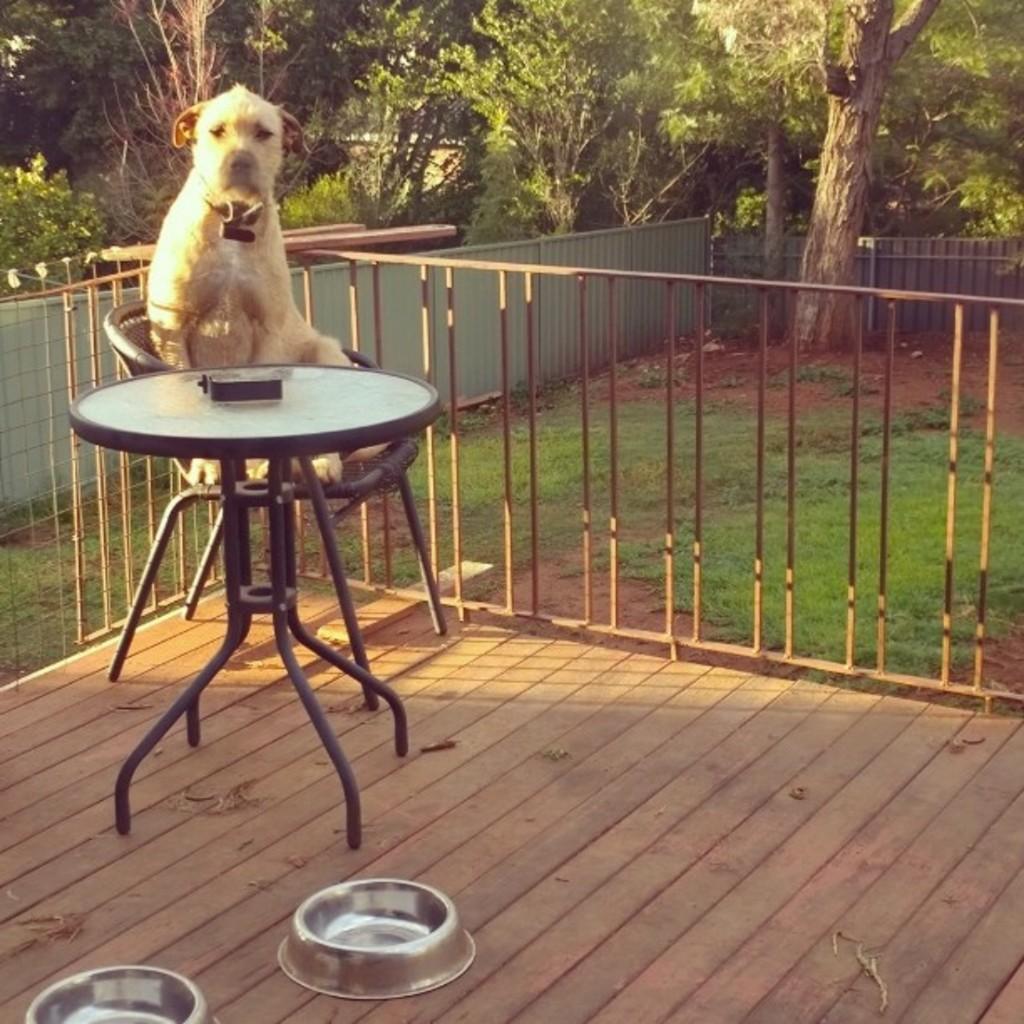Could you give a brief overview of what you see in this image? In this image I can see a dog sitting on the chair there is a table in front of the dog. There are two bowls on the floor. At the back there is a railing and the tree. 